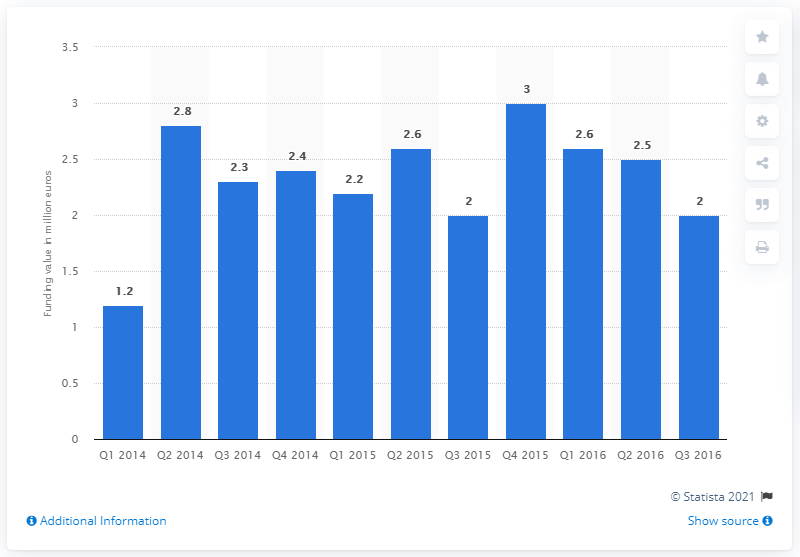Indicate a few pertinent items in this graphic. The amount of funds raised through crowdfunding platforms in Germany in the second quarter of 2015 was approximately 2.6 billion euros. 